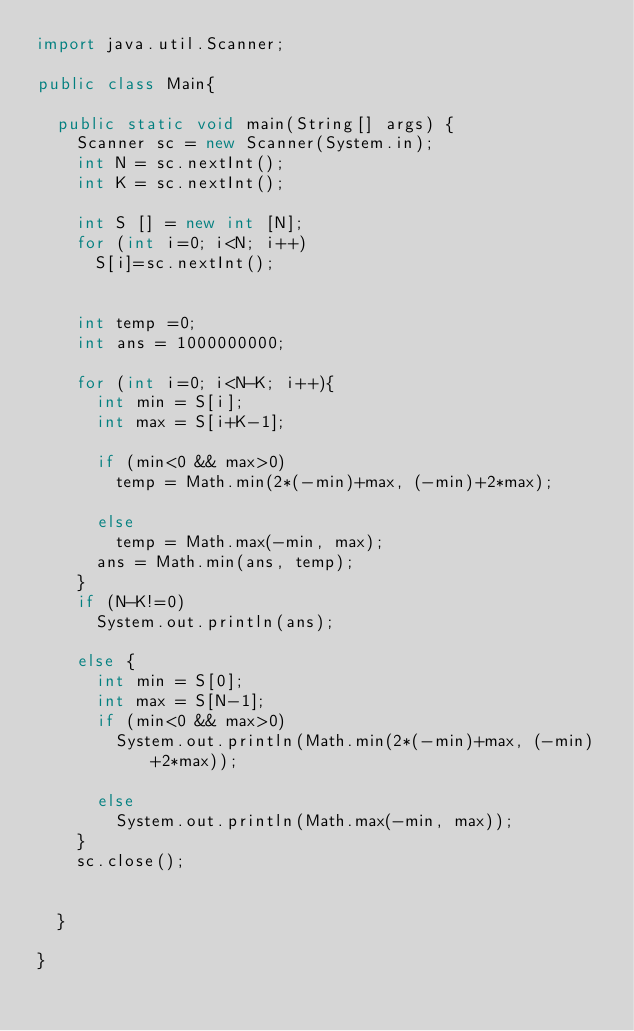<code> <loc_0><loc_0><loc_500><loc_500><_Java_>import java.util.Scanner;

public class Main{

	public static void main(String[] args) {
		Scanner sc = new Scanner(System.in);
		int N = sc.nextInt();
		int K = sc.nextInt();
		
		int S [] = new int [N];
		for (int i=0; i<N; i++)
			S[i]=sc.nextInt();
		
		
		int temp =0;
		int ans = 1000000000;
		
		for (int i=0; i<N-K; i++){
			int min = S[i];
			int max = S[i+K-1];
			
			if (min<0 && max>0)
				temp = Math.min(2*(-min)+max, (-min)+2*max);
			
			else
				temp = Math.max(-min, max);
			ans = Math.min(ans, temp);
		}
		if (N-K!=0)
			System.out.println(ans);
		
		else {
			int min = S[0];
			int max = S[N-1];
			if (min<0 && max>0)
				System.out.println(Math.min(2*(-min)+max, (-min)+2*max));
			
			else
				System.out.println(Math.max(-min, max));
		}
		sc.close();
		
		
	}

}
</code> 